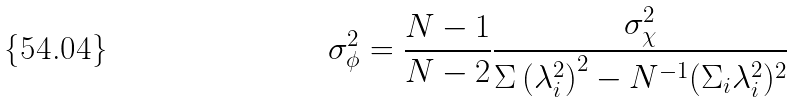<formula> <loc_0><loc_0><loc_500><loc_500>\sigma ^ { 2 } _ { \phi } = \frac { N - 1 } { N - 2 } \frac { \sigma _ { \chi } ^ { 2 } } { \Sigma \left ( \lambda ^ { 2 } _ { i } \right ) ^ { 2 } - N ^ { - 1 } ( \Sigma _ { i } \lambda _ { i } ^ { 2 } ) ^ { 2 } }</formula> 